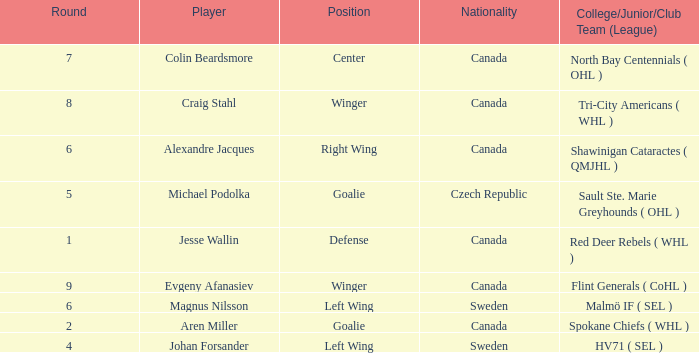What is the School/Junior/Club Group (Class) that has a Nationality of canada, and a Place of goalie? Spokane Chiefs ( WHL ). 